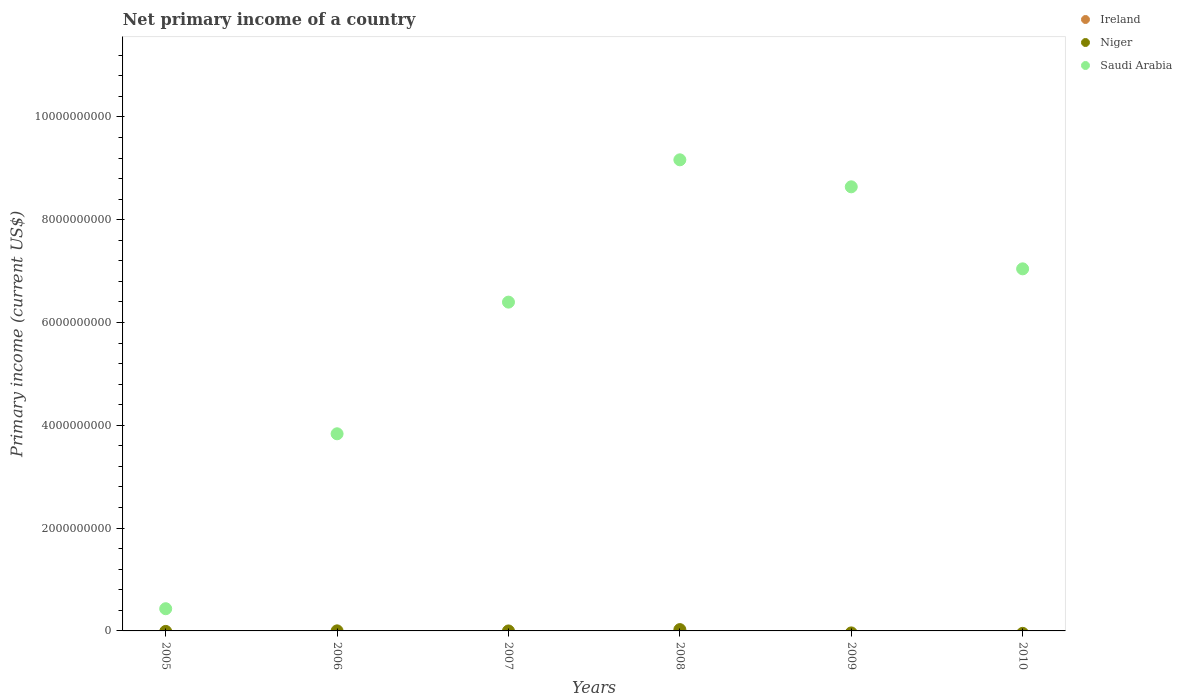How many different coloured dotlines are there?
Offer a terse response. 2. Is the number of dotlines equal to the number of legend labels?
Make the answer very short. No. What is the primary income in Saudi Arabia in 2006?
Make the answer very short. 3.83e+09. Across all years, what is the maximum primary income in Saudi Arabia?
Offer a terse response. 9.16e+09. Across all years, what is the minimum primary income in Saudi Arabia?
Your answer should be compact. 4.32e+08. In which year was the primary income in Niger maximum?
Make the answer very short. 2008. What is the total primary income in Saudi Arabia in the graph?
Your answer should be very brief. 3.55e+1. What is the difference between the primary income in Saudi Arabia in 2005 and that in 2008?
Your answer should be compact. -8.73e+09. What is the average primary income in Ireland per year?
Give a very brief answer. 0. In how many years, is the primary income in Saudi Arabia greater than 10400000000 US$?
Make the answer very short. 0. What is the ratio of the primary income in Saudi Arabia in 2005 to that in 2007?
Provide a short and direct response. 0.07. Is the primary income in Niger in 2006 less than that in 2008?
Your answer should be very brief. Yes. What is the difference between the highest and the lowest primary income in Saudi Arabia?
Make the answer very short. 8.73e+09. Does the primary income in Ireland monotonically increase over the years?
Ensure brevity in your answer.  No. Is the primary income in Ireland strictly less than the primary income in Saudi Arabia over the years?
Your response must be concise. Yes. How many dotlines are there?
Give a very brief answer. 2. What is the difference between two consecutive major ticks on the Y-axis?
Your response must be concise. 2.00e+09. Where does the legend appear in the graph?
Your response must be concise. Top right. How many legend labels are there?
Give a very brief answer. 3. How are the legend labels stacked?
Provide a succinct answer. Vertical. What is the title of the graph?
Give a very brief answer. Net primary income of a country. What is the label or title of the X-axis?
Ensure brevity in your answer.  Years. What is the label or title of the Y-axis?
Give a very brief answer. Primary income (current US$). What is the Primary income (current US$) in Saudi Arabia in 2005?
Your answer should be compact. 4.32e+08. What is the Primary income (current US$) of Niger in 2006?
Make the answer very short. 1.21e+06. What is the Primary income (current US$) of Saudi Arabia in 2006?
Give a very brief answer. 3.83e+09. What is the Primary income (current US$) of Ireland in 2007?
Keep it short and to the point. 0. What is the Primary income (current US$) in Saudi Arabia in 2007?
Keep it short and to the point. 6.40e+09. What is the Primary income (current US$) in Ireland in 2008?
Make the answer very short. 0. What is the Primary income (current US$) of Niger in 2008?
Your response must be concise. 2.57e+07. What is the Primary income (current US$) in Saudi Arabia in 2008?
Provide a short and direct response. 9.16e+09. What is the Primary income (current US$) in Saudi Arabia in 2009?
Provide a short and direct response. 8.64e+09. What is the Primary income (current US$) in Ireland in 2010?
Give a very brief answer. 0. What is the Primary income (current US$) of Niger in 2010?
Your response must be concise. 0. What is the Primary income (current US$) in Saudi Arabia in 2010?
Your answer should be very brief. 7.04e+09. Across all years, what is the maximum Primary income (current US$) in Niger?
Offer a terse response. 2.57e+07. Across all years, what is the maximum Primary income (current US$) in Saudi Arabia?
Provide a succinct answer. 9.16e+09. Across all years, what is the minimum Primary income (current US$) in Saudi Arabia?
Offer a terse response. 4.32e+08. What is the total Primary income (current US$) in Ireland in the graph?
Make the answer very short. 0. What is the total Primary income (current US$) of Niger in the graph?
Your response must be concise. 2.69e+07. What is the total Primary income (current US$) in Saudi Arabia in the graph?
Offer a very short reply. 3.55e+1. What is the difference between the Primary income (current US$) of Saudi Arabia in 2005 and that in 2006?
Your response must be concise. -3.40e+09. What is the difference between the Primary income (current US$) of Saudi Arabia in 2005 and that in 2007?
Provide a short and direct response. -5.96e+09. What is the difference between the Primary income (current US$) of Saudi Arabia in 2005 and that in 2008?
Your answer should be very brief. -8.73e+09. What is the difference between the Primary income (current US$) in Saudi Arabia in 2005 and that in 2009?
Offer a terse response. -8.21e+09. What is the difference between the Primary income (current US$) of Saudi Arabia in 2005 and that in 2010?
Offer a very short reply. -6.61e+09. What is the difference between the Primary income (current US$) in Saudi Arabia in 2006 and that in 2007?
Offer a terse response. -2.56e+09. What is the difference between the Primary income (current US$) of Niger in 2006 and that in 2008?
Offer a terse response. -2.45e+07. What is the difference between the Primary income (current US$) in Saudi Arabia in 2006 and that in 2008?
Provide a succinct answer. -5.33e+09. What is the difference between the Primary income (current US$) in Saudi Arabia in 2006 and that in 2009?
Your answer should be compact. -4.80e+09. What is the difference between the Primary income (current US$) of Saudi Arabia in 2006 and that in 2010?
Your answer should be compact. -3.21e+09. What is the difference between the Primary income (current US$) of Saudi Arabia in 2007 and that in 2008?
Offer a terse response. -2.77e+09. What is the difference between the Primary income (current US$) of Saudi Arabia in 2007 and that in 2009?
Your response must be concise. -2.24e+09. What is the difference between the Primary income (current US$) in Saudi Arabia in 2007 and that in 2010?
Provide a succinct answer. -6.48e+08. What is the difference between the Primary income (current US$) in Saudi Arabia in 2008 and that in 2009?
Your response must be concise. 5.25e+08. What is the difference between the Primary income (current US$) in Saudi Arabia in 2008 and that in 2010?
Your answer should be very brief. 2.12e+09. What is the difference between the Primary income (current US$) of Saudi Arabia in 2009 and that in 2010?
Ensure brevity in your answer.  1.60e+09. What is the difference between the Primary income (current US$) of Niger in 2006 and the Primary income (current US$) of Saudi Arabia in 2007?
Offer a very short reply. -6.40e+09. What is the difference between the Primary income (current US$) in Niger in 2006 and the Primary income (current US$) in Saudi Arabia in 2008?
Make the answer very short. -9.16e+09. What is the difference between the Primary income (current US$) of Niger in 2006 and the Primary income (current US$) of Saudi Arabia in 2009?
Provide a succinct answer. -8.64e+09. What is the difference between the Primary income (current US$) of Niger in 2006 and the Primary income (current US$) of Saudi Arabia in 2010?
Offer a very short reply. -7.04e+09. What is the difference between the Primary income (current US$) in Niger in 2008 and the Primary income (current US$) in Saudi Arabia in 2009?
Ensure brevity in your answer.  -8.61e+09. What is the difference between the Primary income (current US$) in Niger in 2008 and the Primary income (current US$) in Saudi Arabia in 2010?
Provide a short and direct response. -7.02e+09. What is the average Primary income (current US$) of Ireland per year?
Ensure brevity in your answer.  0. What is the average Primary income (current US$) in Niger per year?
Ensure brevity in your answer.  4.49e+06. What is the average Primary income (current US$) in Saudi Arabia per year?
Offer a very short reply. 5.92e+09. In the year 2006, what is the difference between the Primary income (current US$) of Niger and Primary income (current US$) of Saudi Arabia?
Provide a short and direct response. -3.83e+09. In the year 2008, what is the difference between the Primary income (current US$) of Niger and Primary income (current US$) of Saudi Arabia?
Ensure brevity in your answer.  -9.14e+09. What is the ratio of the Primary income (current US$) in Saudi Arabia in 2005 to that in 2006?
Offer a very short reply. 0.11. What is the ratio of the Primary income (current US$) of Saudi Arabia in 2005 to that in 2007?
Offer a very short reply. 0.07. What is the ratio of the Primary income (current US$) of Saudi Arabia in 2005 to that in 2008?
Make the answer very short. 0.05. What is the ratio of the Primary income (current US$) of Saudi Arabia in 2005 to that in 2010?
Your answer should be very brief. 0.06. What is the ratio of the Primary income (current US$) of Saudi Arabia in 2006 to that in 2007?
Your response must be concise. 0.6. What is the ratio of the Primary income (current US$) in Niger in 2006 to that in 2008?
Give a very brief answer. 0.05. What is the ratio of the Primary income (current US$) of Saudi Arabia in 2006 to that in 2008?
Keep it short and to the point. 0.42. What is the ratio of the Primary income (current US$) in Saudi Arabia in 2006 to that in 2009?
Keep it short and to the point. 0.44. What is the ratio of the Primary income (current US$) of Saudi Arabia in 2006 to that in 2010?
Make the answer very short. 0.54. What is the ratio of the Primary income (current US$) of Saudi Arabia in 2007 to that in 2008?
Provide a short and direct response. 0.7. What is the ratio of the Primary income (current US$) of Saudi Arabia in 2007 to that in 2009?
Provide a succinct answer. 0.74. What is the ratio of the Primary income (current US$) of Saudi Arabia in 2007 to that in 2010?
Give a very brief answer. 0.91. What is the ratio of the Primary income (current US$) of Saudi Arabia in 2008 to that in 2009?
Offer a terse response. 1.06. What is the ratio of the Primary income (current US$) in Saudi Arabia in 2008 to that in 2010?
Give a very brief answer. 1.3. What is the ratio of the Primary income (current US$) of Saudi Arabia in 2009 to that in 2010?
Offer a terse response. 1.23. What is the difference between the highest and the second highest Primary income (current US$) in Saudi Arabia?
Your response must be concise. 5.25e+08. What is the difference between the highest and the lowest Primary income (current US$) of Niger?
Provide a short and direct response. 2.57e+07. What is the difference between the highest and the lowest Primary income (current US$) in Saudi Arabia?
Offer a terse response. 8.73e+09. 